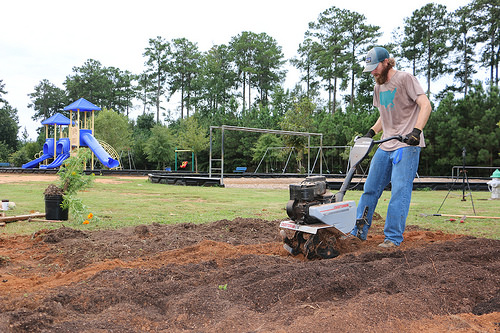<image>
Is there a tree behind the man? No. The tree is not behind the man. From this viewpoint, the tree appears to be positioned elsewhere in the scene. Where is the man in relation to the dirt? Is it above the dirt? No. The man is not positioned above the dirt. The vertical arrangement shows a different relationship. 